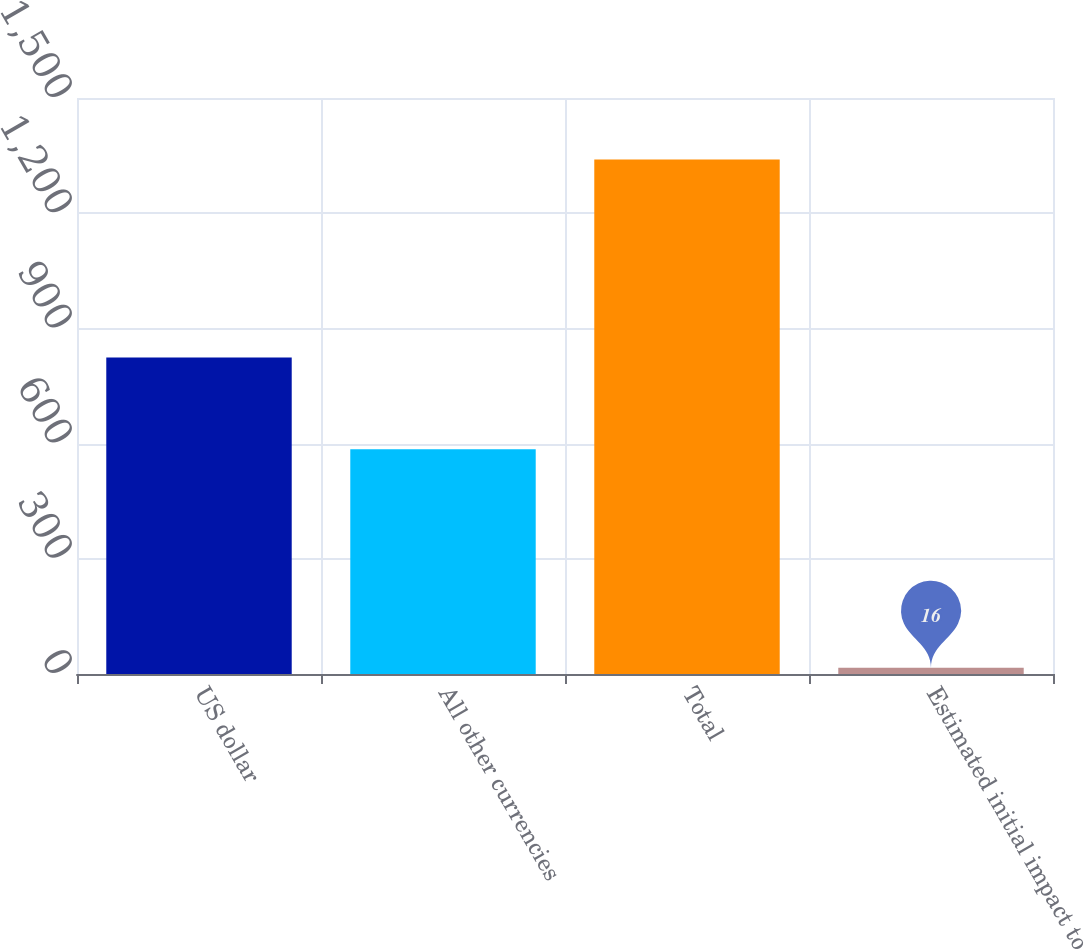<chart> <loc_0><loc_0><loc_500><loc_500><bar_chart><fcel>US dollar<fcel>All other currencies<fcel>Total<fcel>Estimated initial impact to<nl><fcel>823.9<fcel>585<fcel>1340<fcel>16<nl></chart> 